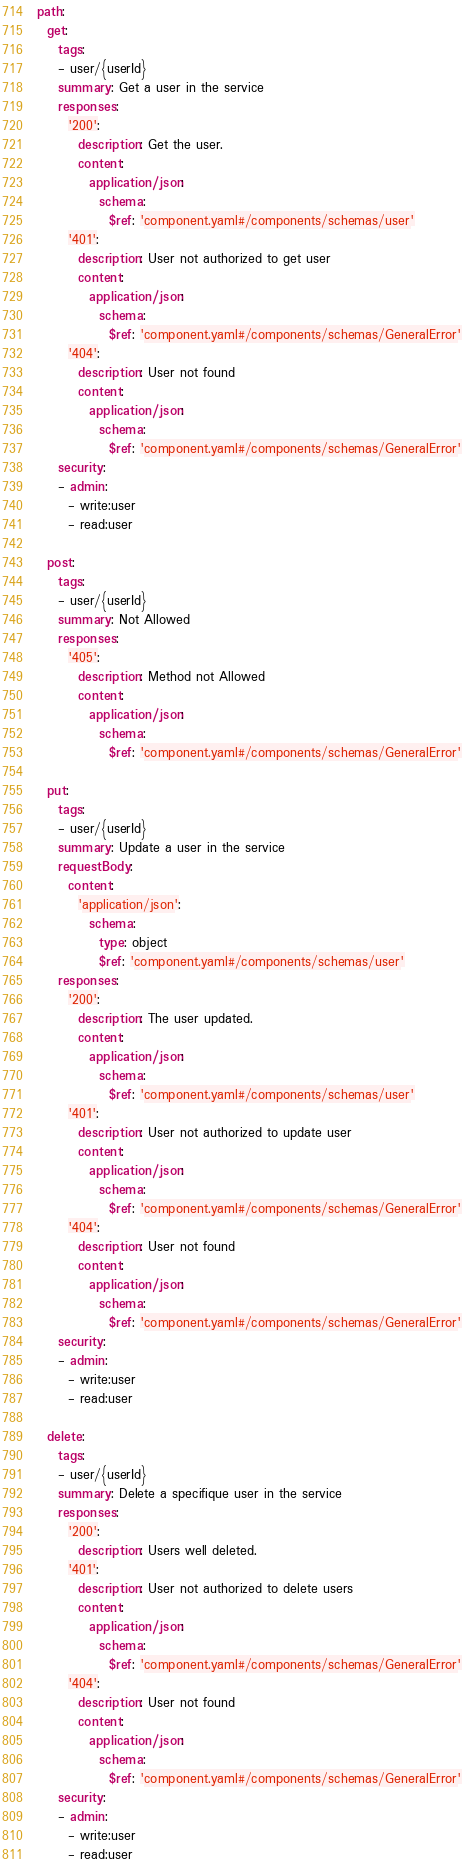Convert code to text. <code><loc_0><loc_0><loc_500><loc_500><_YAML_>path:
  get:
    tags:
    - user/{userId}
    summary: Get a user in the service
    responses:
      '200':
        description: Get the user.
        content:
          application/json:
            schema:
              $ref: 'component.yaml#/components/schemas/user'
      '401':
        description: User not authorized to get user
        content:
          application/json:
            schema:
              $ref: 'component.yaml#/components/schemas/GeneralError'
      '404':
        description: User not found
        content:
          application/json:
            schema:
              $ref: 'component.yaml#/components/schemas/GeneralError'
    security:
    - admin:
      - write:user
      - read:user

  post:
    tags:
    - user/{userId}
    summary: Not Allowed
    responses:
      '405':
        description: Method not Allowed
        content:
          application/json:
            schema:
              $ref: 'component.yaml#/components/schemas/GeneralError'

  put:
    tags:
    - user/{userId}
    summary: Update a user in the service
    requestBody:
      content:
        'application/json':
          schema:
            type: object
            $ref: 'component.yaml#/components/schemas/user'
    responses:
      '200':
        description: The user updated.
        content:
          application/json:
            schema:
              $ref: 'component.yaml#/components/schemas/user'
      '401':
        description: User not authorized to update user
        content:
          application/json:
            schema:
              $ref: 'component.yaml#/components/schemas/GeneralError'
      '404':
        description: User not found
        content:
          application/json:
            schema:
              $ref: 'component.yaml#/components/schemas/GeneralError'
    security:
    - admin:
      - write:user
      - read:user

  delete:
    tags:
    - user/{userId}
    summary: Delete a specifique user in the service
    responses:
      '200':
        description: Users well deleted.
      '401':
        description: User not authorized to delete users
        content:
          application/json:
            schema:
              $ref: 'component.yaml#/components/schemas/GeneralError'
      '404':
        description: User not found
        content:
          application/json:
            schema:
              $ref: 'component.yaml#/components/schemas/GeneralError'
    security:
    - admin:
      - write:user
      - read:user
</code> 